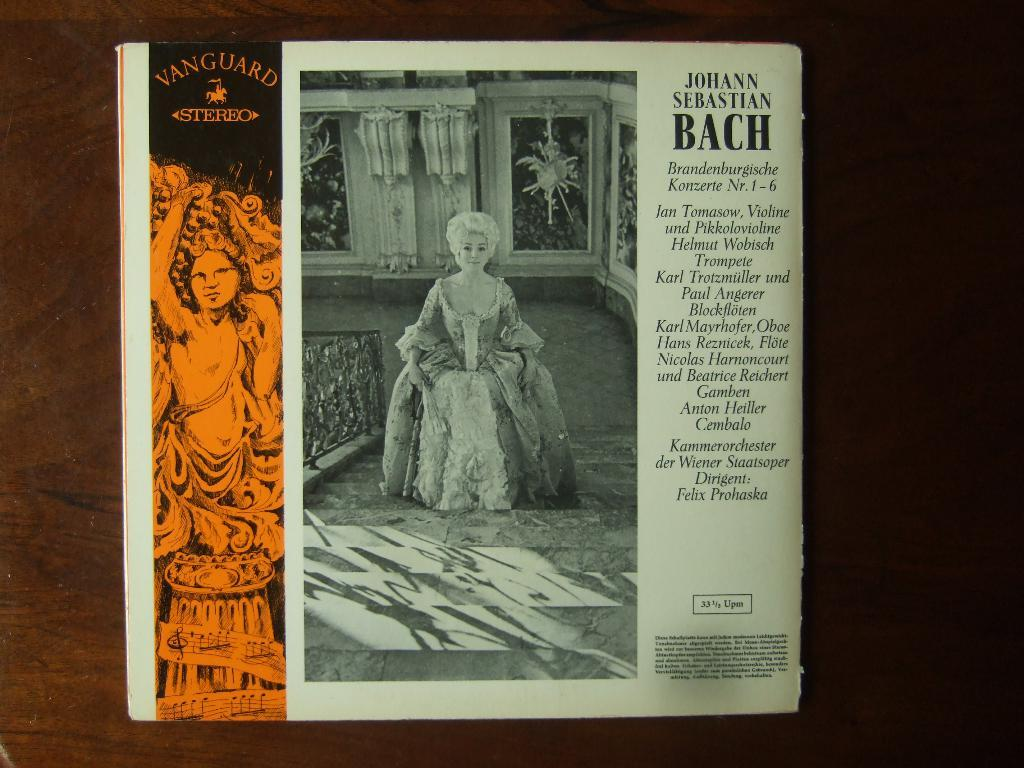<image>
Present a compact description of the photo's key features. A magazine article about Johann Sebastian Bach with a black and white photo. 